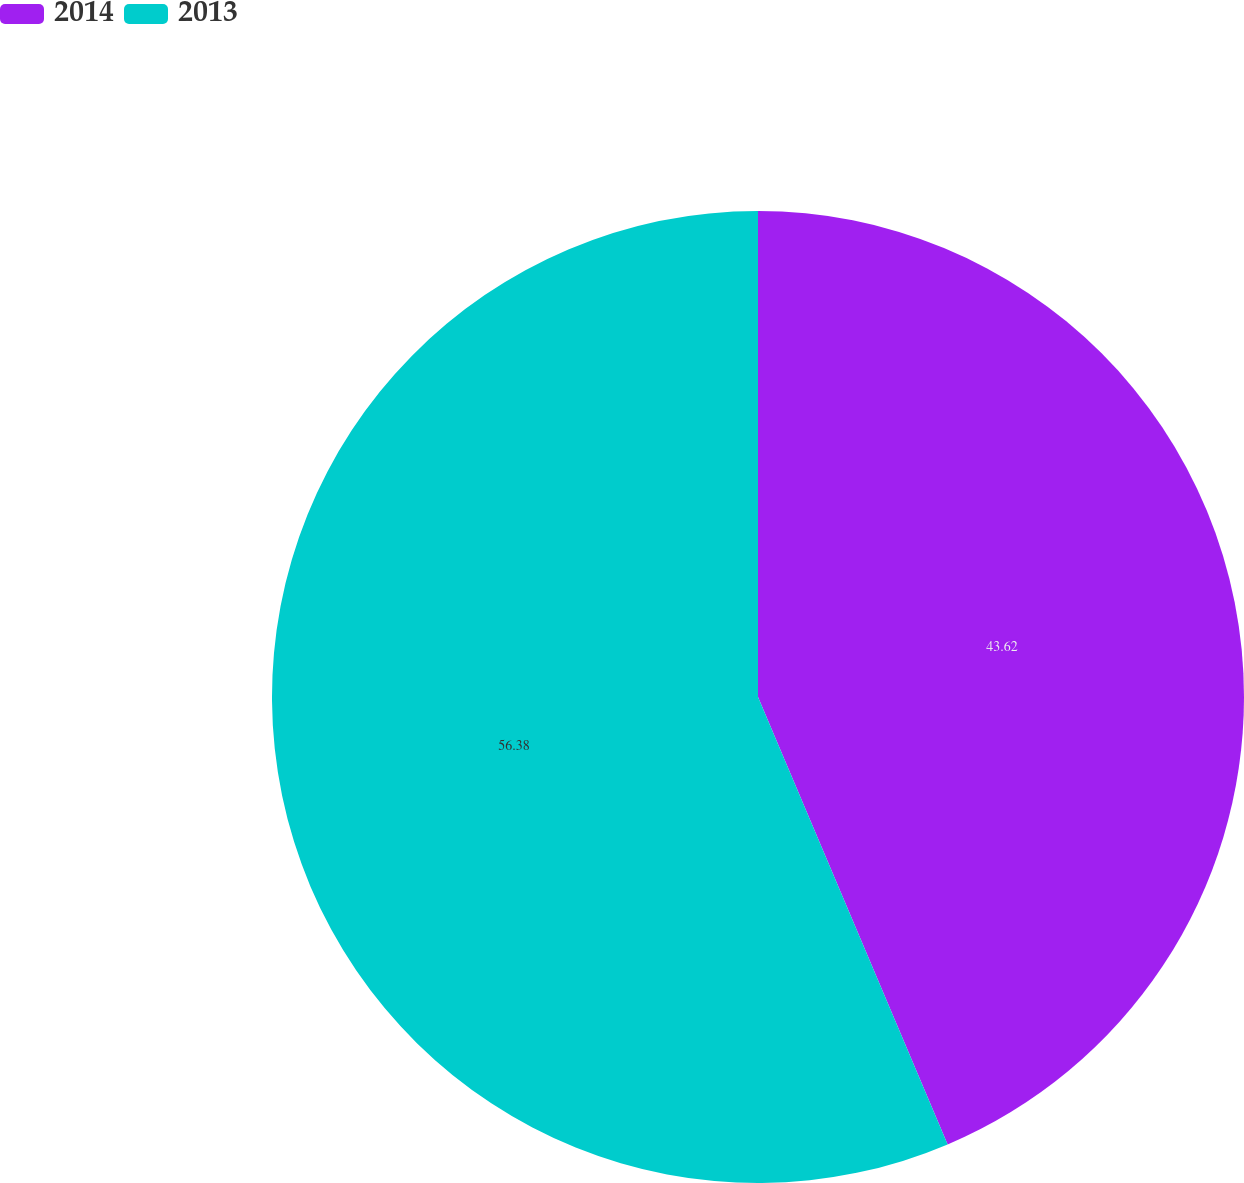Convert chart. <chart><loc_0><loc_0><loc_500><loc_500><pie_chart><fcel>2014<fcel>2013<nl><fcel>43.62%<fcel>56.38%<nl></chart> 